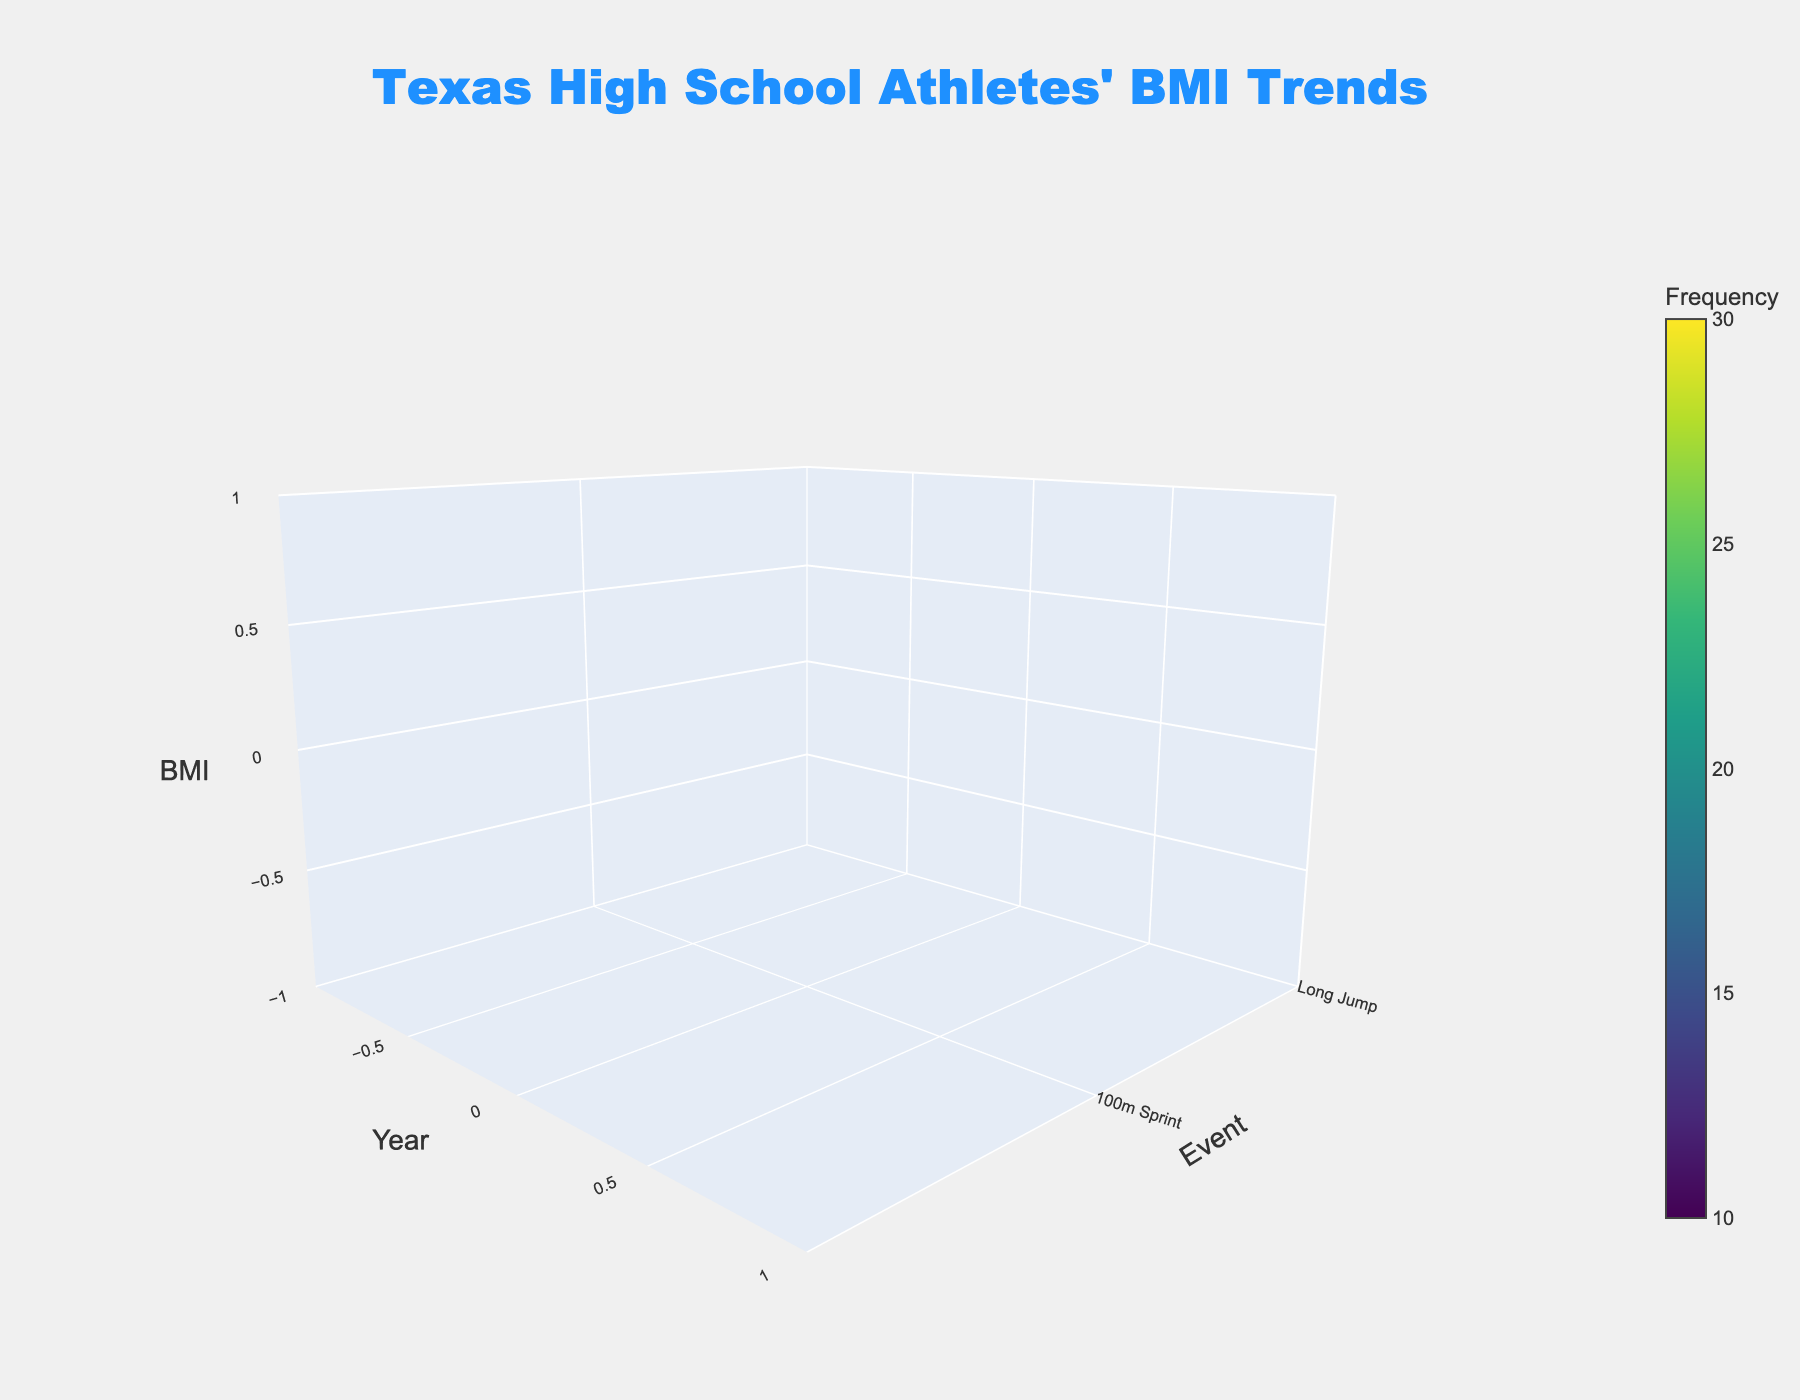What does the title of the figure indicate? The title "Texas High School Athletes' BMI Trends" likely indicates that the figure is showing how BMI values for Texas high school athletes have changed over time, categorized by different event specializations in track and field.
Answer: Texas High School Athletes' BMI Trends Which event shows the highest BMI in 2020? Looking at the event dimension for 2020 and checking the BMI axis, we can see that the Shot Put event has the highest BMI among all the events.
Answer: Shot Put How does the BMI trend of Shot Put athletes change from 2010 to 2020? By inspecting the Shot Put traces over the years on the BMI axis, we see a consistent increase from 26.8 in 2010 to 27.9 in 2020.
Answer: It increases Which year had the lowest average BMI across all events? Averaging the BMI values for each event per year, we find that 2010 has the lowest average: (20.5 + 21.2 + 26.8 + 20.1) / 4 = 22.15.
Answer: 2010 Which event specialization shows the least variable BMI trend over the years? Comparing the spread of BMI values across the years for each event, the High Jump shows the least variability, staying close to 20.1 to 21.1.
Answer: High Jump Is there any event whose BMI trend shows a consistently increasing pattern over the years? Observing the BMI trends for all events, we see that the BMI for Shot Put shows a consistent increase from 2010 to 2020.
Answer: Shot Put What is the general relationship between the frequency of athletes and their BMI values? By examining the color intensity of the volumes, we infer that higher frequencies tend to correspond to higher BMIs, particularly in the Shot Put event where both BMI and frequency increase.
Answer: Higher BMIs have higher frequencies 